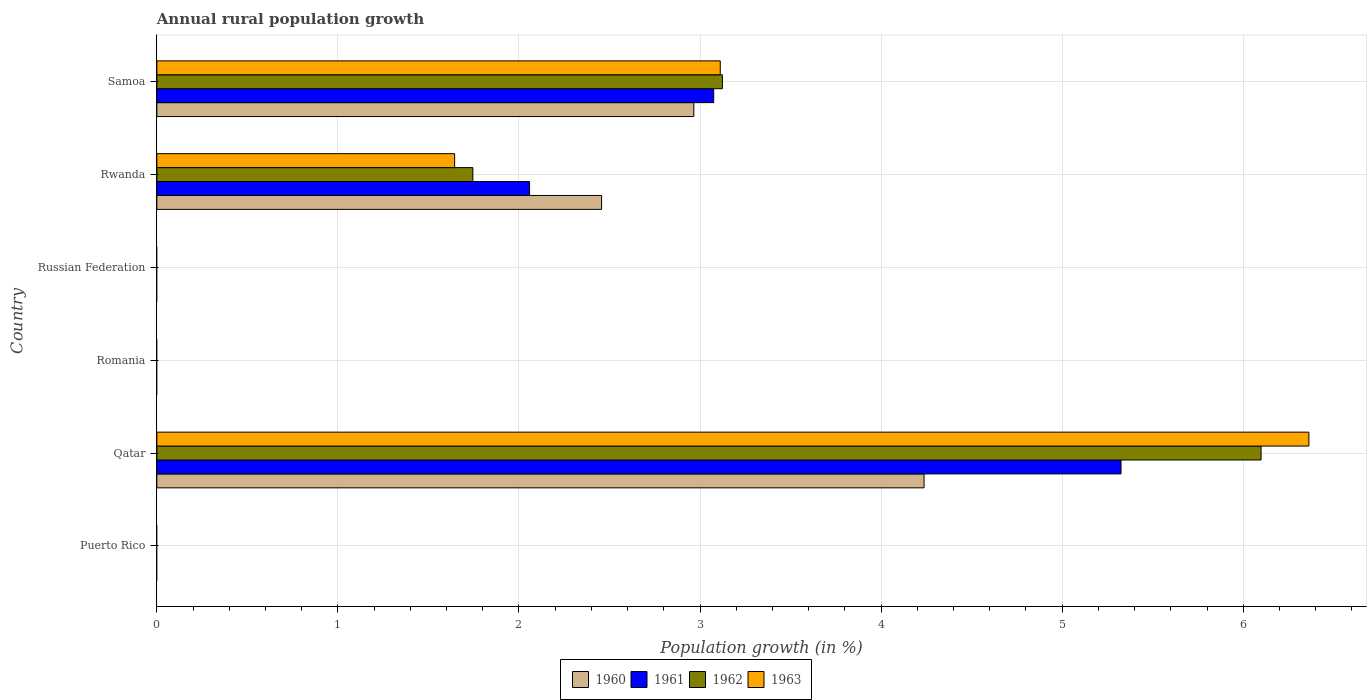How many different coloured bars are there?
Provide a short and direct response. 4. How many bars are there on the 6th tick from the top?
Your answer should be compact. 0. How many bars are there on the 6th tick from the bottom?
Provide a succinct answer. 4. What is the label of the 1st group of bars from the top?
Your answer should be compact. Samoa. In how many cases, is the number of bars for a given country not equal to the number of legend labels?
Make the answer very short. 3. What is the percentage of rural population growth in 1963 in Qatar?
Your answer should be compact. 6.36. Across all countries, what is the maximum percentage of rural population growth in 1961?
Make the answer very short. 5.33. In which country was the percentage of rural population growth in 1960 maximum?
Offer a very short reply. Qatar. What is the total percentage of rural population growth in 1962 in the graph?
Give a very brief answer. 10.97. What is the difference between the percentage of rural population growth in 1963 in Rwanda and that in Samoa?
Your answer should be very brief. -1.47. What is the difference between the percentage of rural population growth in 1960 in Puerto Rico and the percentage of rural population growth in 1962 in Samoa?
Make the answer very short. -3.12. What is the average percentage of rural population growth in 1960 per country?
Give a very brief answer. 1.61. What is the difference between the percentage of rural population growth in 1961 and percentage of rural population growth in 1960 in Rwanda?
Give a very brief answer. -0.4. In how many countries, is the percentage of rural population growth in 1960 greater than 2 %?
Your answer should be very brief. 3. What is the difference between the highest and the second highest percentage of rural population growth in 1960?
Your answer should be compact. 1.27. What is the difference between the highest and the lowest percentage of rural population growth in 1961?
Your response must be concise. 5.33. In how many countries, is the percentage of rural population growth in 1962 greater than the average percentage of rural population growth in 1962 taken over all countries?
Ensure brevity in your answer.  2. How many bars are there?
Provide a short and direct response. 12. Are the values on the major ticks of X-axis written in scientific E-notation?
Offer a terse response. No. Does the graph contain any zero values?
Your response must be concise. Yes. What is the title of the graph?
Your answer should be compact. Annual rural population growth. Does "1987" appear as one of the legend labels in the graph?
Make the answer very short. No. What is the label or title of the X-axis?
Provide a short and direct response. Population growth (in %). What is the label or title of the Y-axis?
Ensure brevity in your answer.  Country. What is the Population growth (in %) of 1960 in Puerto Rico?
Your answer should be compact. 0. What is the Population growth (in %) of 1961 in Puerto Rico?
Give a very brief answer. 0. What is the Population growth (in %) in 1963 in Puerto Rico?
Provide a short and direct response. 0. What is the Population growth (in %) of 1960 in Qatar?
Make the answer very short. 4.24. What is the Population growth (in %) of 1961 in Qatar?
Your response must be concise. 5.33. What is the Population growth (in %) of 1962 in Qatar?
Provide a succinct answer. 6.1. What is the Population growth (in %) in 1963 in Qatar?
Make the answer very short. 6.36. What is the Population growth (in %) in 1960 in Romania?
Your answer should be very brief. 0. What is the Population growth (in %) in 1961 in Romania?
Provide a short and direct response. 0. What is the Population growth (in %) of 1962 in Romania?
Keep it short and to the point. 0. What is the Population growth (in %) in 1963 in Romania?
Offer a very short reply. 0. What is the Population growth (in %) of 1960 in Russian Federation?
Your answer should be compact. 0. What is the Population growth (in %) in 1960 in Rwanda?
Make the answer very short. 2.46. What is the Population growth (in %) of 1961 in Rwanda?
Provide a short and direct response. 2.06. What is the Population growth (in %) in 1962 in Rwanda?
Give a very brief answer. 1.75. What is the Population growth (in %) of 1963 in Rwanda?
Keep it short and to the point. 1.64. What is the Population growth (in %) of 1960 in Samoa?
Offer a very short reply. 2.97. What is the Population growth (in %) of 1961 in Samoa?
Your answer should be compact. 3.08. What is the Population growth (in %) of 1962 in Samoa?
Your answer should be very brief. 3.12. What is the Population growth (in %) in 1963 in Samoa?
Keep it short and to the point. 3.11. Across all countries, what is the maximum Population growth (in %) in 1960?
Offer a terse response. 4.24. Across all countries, what is the maximum Population growth (in %) in 1961?
Give a very brief answer. 5.33. Across all countries, what is the maximum Population growth (in %) in 1962?
Your response must be concise. 6.1. Across all countries, what is the maximum Population growth (in %) in 1963?
Your answer should be very brief. 6.36. Across all countries, what is the minimum Population growth (in %) of 1961?
Your answer should be very brief. 0. Across all countries, what is the minimum Population growth (in %) in 1962?
Ensure brevity in your answer.  0. Across all countries, what is the minimum Population growth (in %) in 1963?
Offer a very short reply. 0. What is the total Population growth (in %) of 1960 in the graph?
Offer a very short reply. 9.66. What is the total Population growth (in %) of 1961 in the graph?
Ensure brevity in your answer.  10.46. What is the total Population growth (in %) in 1962 in the graph?
Your answer should be compact. 10.97. What is the total Population growth (in %) of 1963 in the graph?
Give a very brief answer. 11.12. What is the difference between the Population growth (in %) in 1960 in Qatar and that in Rwanda?
Offer a terse response. 1.78. What is the difference between the Population growth (in %) of 1961 in Qatar and that in Rwanda?
Your response must be concise. 3.27. What is the difference between the Population growth (in %) of 1962 in Qatar and that in Rwanda?
Provide a short and direct response. 4.35. What is the difference between the Population growth (in %) of 1963 in Qatar and that in Rwanda?
Give a very brief answer. 4.72. What is the difference between the Population growth (in %) of 1960 in Qatar and that in Samoa?
Your response must be concise. 1.27. What is the difference between the Population growth (in %) in 1961 in Qatar and that in Samoa?
Make the answer very short. 2.25. What is the difference between the Population growth (in %) in 1962 in Qatar and that in Samoa?
Make the answer very short. 2.98. What is the difference between the Population growth (in %) in 1963 in Qatar and that in Samoa?
Provide a short and direct response. 3.25. What is the difference between the Population growth (in %) in 1960 in Rwanda and that in Samoa?
Make the answer very short. -0.51. What is the difference between the Population growth (in %) of 1961 in Rwanda and that in Samoa?
Provide a short and direct response. -1.02. What is the difference between the Population growth (in %) in 1962 in Rwanda and that in Samoa?
Your answer should be compact. -1.38. What is the difference between the Population growth (in %) in 1963 in Rwanda and that in Samoa?
Ensure brevity in your answer.  -1.47. What is the difference between the Population growth (in %) in 1960 in Qatar and the Population growth (in %) in 1961 in Rwanda?
Offer a very short reply. 2.18. What is the difference between the Population growth (in %) in 1960 in Qatar and the Population growth (in %) in 1962 in Rwanda?
Provide a succinct answer. 2.49. What is the difference between the Population growth (in %) in 1960 in Qatar and the Population growth (in %) in 1963 in Rwanda?
Offer a very short reply. 2.59. What is the difference between the Population growth (in %) of 1961 in Qatar and the Population growth (in %) of 1962 in Rwanda?
Offer a terse response. 3.58. What is the difference between the Population growth (in %) of 1961 in Qatar and the Population growth (in %) of 1963 in Rwanda?
Your answer should be compact. 3.68. What is the difference between the Population growth (in %) in 1962 in Qatar and the Population growth (in %) in 1963 in Rwanda?
Ensure brevity in your answer.  4.45. What is the difference between the Population growth (in %) of 1960 in Qatar and the Population growth (in %) of 1961 in Samoa?
Offer a very short reply. 1.16. What is the difference between the Population growth (in %) in 1960 in Qatar and the Population growth (in %) in 1962 in Samoa?
Make the answer very short. 1.11. What is the difference between the Population growth (in %) of 1960 in Qatar and the Population growth (in %) of 1963 in Samoa?
Provide a short and direct response. 1.13. What is the difference between the Population growth (in %) in 1961 in Qatar and the Population growth (in %) in 1962 in Samoa?
Provide a succinct answer. 2.2. What is the difference between the Population growth (in %) of 1961 in Qatar and the Population growth (in %) of 1963 in Samoa?
Offer a very short reply. 2.21. What is the difference between the Population growth (in %) in 1962 in Qatar and the Population growth (in %) in 1963 in Samoa?
Offer a terse response. 2.99. What is the difference between the Population growth (in %) of 1960 in Rwanda and the Population growth (in %) of 1961 in Samoa?
Provide a short and direct response. -0.62. What is the difference between the Population growth (in %) of 1960 in Rwanda and the Population growth (in %) of 1962 in Samoa?
Your response must be concise. -0.67. What is the difference between the Population growth (in %) in 1960 in Rwanda and the Population growth (in %) in 1963 in Samoa?
Give a very brief answer. -0.66. What is the difference between the Population growth (in %) in 1961 in Rwanda and the Population growth (in %) in 1962 in Samoa?
Offer a terse response. -1.07. What is the difference between the Population growth (in %) in 1961 in Rwanda and the Population growth (in %) in 1963 in Samoa?
Provide a short and direct response. -1.05. What is the difference between the Population growth (in %) of 1962 in Rwanda and the Population growth (in %) of 1963 in Samoa?
Ensure brevity in your answer.  -1.37. What is the average Population growth (in %) in 1960 per country?
Your answer should be very brief. 1.61. What is the average Population growth (in %) of 1961 per country?
Offer a very short reply. 1.74. What is the average Population growth (in %) of 1962 per country?
Make the answer very short. 1.83. What is the average Population growth (in %) of 1963 per country?
Your answer should be very brief. 1.85. What is the difference between the Population growth (in %) in 1960 and Population growth (in %) in 1961 in Qatar?
Ensure brevity in your answer.  -1.09. What is the difference between the Population growth (in %) in 1960 and Population growth (in %) in 1962 in Qatar?
Your answer should be compact. -1.86. What is the difference between the Population growth (in %) of 1960 and Population growth (in %) of 1963 in Qatar?
Provide a succinct answer. -2.13. What is the difference between the Population growth (in %) of 1961 and Population growth (in %) of 1962 in Qatar?
Ensure brevity in your answer.  -0.77. What is the difference between the Population growth (in %) of 1961 and Population growth (in %) of 1963 in Qatar?
Make the answer very short. -1.04. What is the difference between the Population growth (in %) of 1962 and Population growth (in %) of 1963 in Qatar?
Offer a terse response. -0.26. What is the difference between the Population growth (in %) in 1960 and Population growth (in %) in 1961 in Rwanda?
Provide a succinct answer. 0.4. What is the difference between the Population growth (in %) of 1960 and Population growth (in %) of 1962 in Rwanda?
Your answer should be very brief. 0.71. What is the difference between the Population growth (in %) of 1960 and Population growth (in %) of 1963 in Rwanda?
Your answer should be very brief. 0.81. What is the difference between the Population growth (in %) in 1961 and Population growth (in %) in 1962 in Rwanda?
Provide a short and direct response. 0.31. What is the difference between the Population growth (in %) in 1961 and Population growth (in %) in 1963 in Rwanda?
Offer a very short reply. 0.41. What is the difference between the Population growth (in %) of 1962 and Population growth (in %) of 1963 in Rwanda?
Ensure brevity in your answer.  0.1. What is the difference between the Population growth (in %) of 1960 and Population growth (in %) of 1961 in Samoa?
Your response must be concise. -0.11. What is the difference between the Population growth (in %) in 1960 and Population growth (in %) in 1962 in Samoa?
Keep it short and to the point. -0.16. What is the difference between the Population growth (in %) of 1960 and Population growth (in %) of 1963 in Samoa?
Keep it short and to the point. -0.15. What is the difference between the Population growth (in %) of 1961 and Population growth (in %) of 1962 in Samoa?
Your response must be concise. -0.05. What is the difference between the Population growth (in %) in 1961 and Population growth (in %) in 1963 in Samoa?
Give a very brief answer. -0.04. What is the difference between the Population growth (in %) of 1962 and Population growth (in %) of 1963 in Samoa?
Offer a very short reply. 0.01. What is the ratio of the Population growth (in %) of 1960 in Qatar to that in Rwanda?
Your answer should be compact. 1.73. What is the ratio of the Population growth (in %) in 1961 in Qatar to that in Rwanda?
Keep it short and to the point. 2.59. What is the ratio of the Population growth (in %) of 1962 in Qatar to that in Rwanda?
Your answer should be compact. 3.49. What is the ratio of the Population growth (in %) of 1963 in Qatar to that in Rwanda?
Your response must be concise. 3.87. What is the ratio of the Population growth (in %) in 1960 in Qatar to that in Samoa?
Keep it short and to the point. 1.43. What is the ratio of the Population growth (in %) of 1961 in Qatar to that in Samoa?
Your answer should be very brief. 1.73. What is the ratio of the Population growth (in %) in 1962 in Qatar to that in Samoa?
Keep it short and to the point. 1.95. What is the ratio of the Population growth (in %) in 1963 in Qatar to that in Samoa?
Your answer should be very brief. 2.04. What is the ratio of the Population growth (in %) in 1960 in Rwanda to that in Samoa?
Make the answer very short. 0.83. What is the ratio of the Population growth (in %) of 1961 in Rwanda to that in Samoa?
Provide a succinct answer. 0.67. What is the ratio of the Population growth (in %) in 1962 in Rwanda to that in Samoa?
Offer a very short reply. 0.56. What is the ratio of the Population growth (in %) of 1963 in Rwanda to that in Samoa?
Offer a terse response. 0.53. What is the difference between the highest and the second highest Population growth (in %) of 1960?
Offer a very short reply. 1.27. What is the difference between the highest and the second highest Population growth (in %) in 1961?
Give a very brief answer. 2.25. What is the difference between the highest and the second highest Population growth (in %) in 1962?
Give a very brief answer. 2.98. What is the difference between the highest and the second highest Population growth (in %) of 1963?
Make the answer very short. 3.25. What is the difference between the highest and the lowest Population growth (in %) in 1960?
Your answer should be very brief. 4.24. What is the difference between the highest and the lowest Population growth (in %) of 1961?
Provide a short and direct response. 5.33. What is the difference between the highest and the lowest Population growth (in %) in 1962?
Your response must be concise. 6.1. What is the difference between the highest and the lowest Population growth (in %) of 1963?
Your answer should be compact. 6.36. 